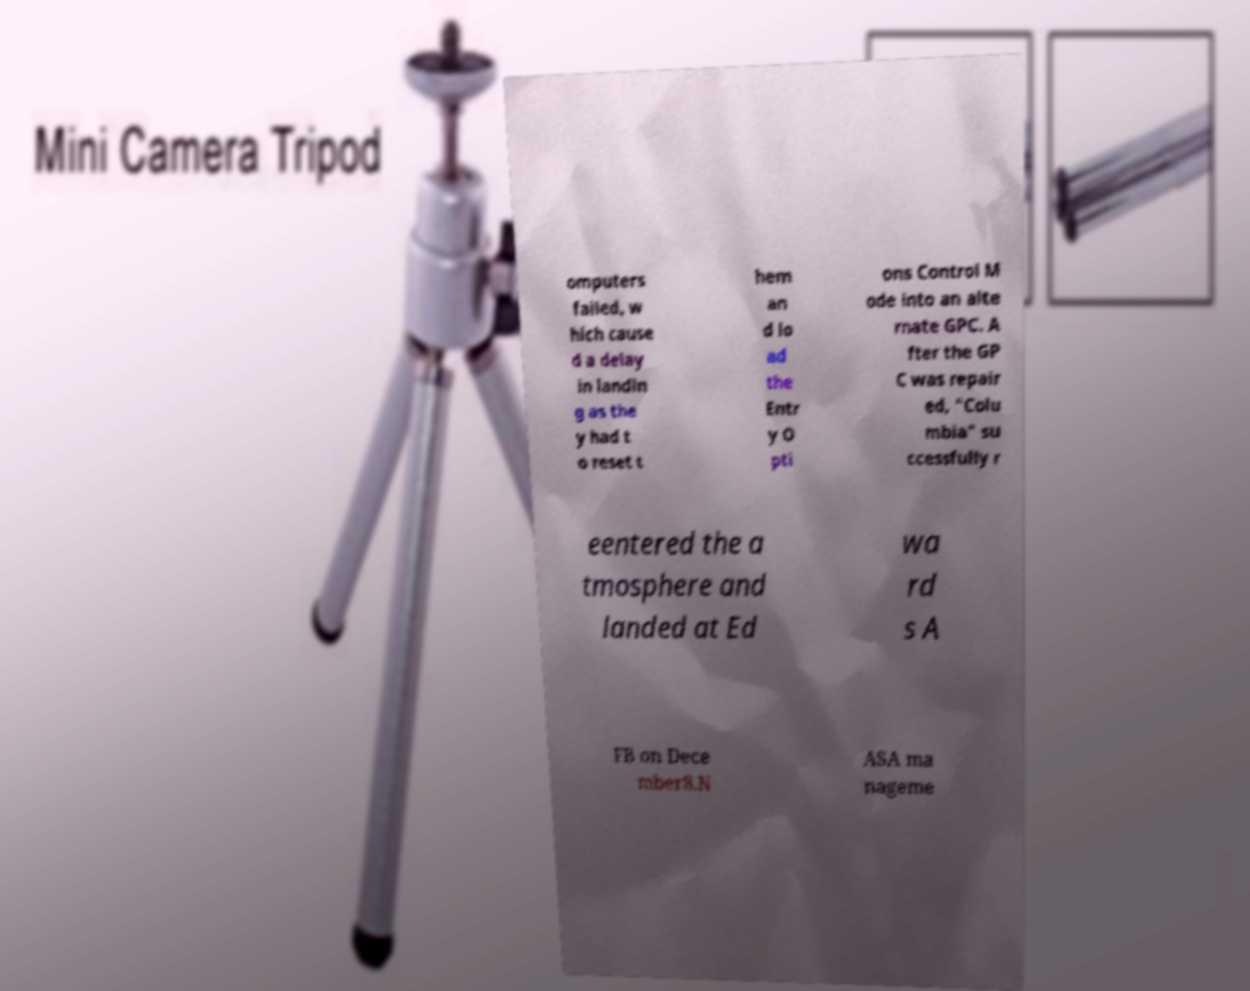Could you extract and type out the text from this image? omputers failed, w hich cause d a delay in landin g as the y had t o reset t hem an d lo ad the Entr y O pti ons Control M ode into an alte rnate GPC. A fter the GP C was repair ed, "Colu mbia" su ccessfully r eentered the a tmosphere and landed at Ed wa rd s A FB on Dece mber8.N ASA ma nageme 